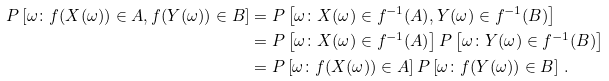<formula> <loc_0><loc_0><loc_500><loc_500>P \left [ \omega \colon f ( X ( \omega ) ) \in A , f ( Y ( \omega ) ) \in B \right ] & = P \left [ \omega \colon X ( \omega ) \in f ^ { - 1 } ( A ) , Y ( \omega ) \in f ^ { - 1 } ( B ) \right ] \\ & = P \left [ \omega \colon X ( \omega ) \in f ^ { - 1 } ( A ) \right ] P \left [ \omega \colon Y ( \omega ) \in f ^ { - 1 } ( B ) \right ] \\ & = P \left [ \omega \colon f ( X ( \omega ) ) \in A \right ] P \left [ \omega \colon f ( Y ( \omega ) ) \in B \right ] \, .</formula> 